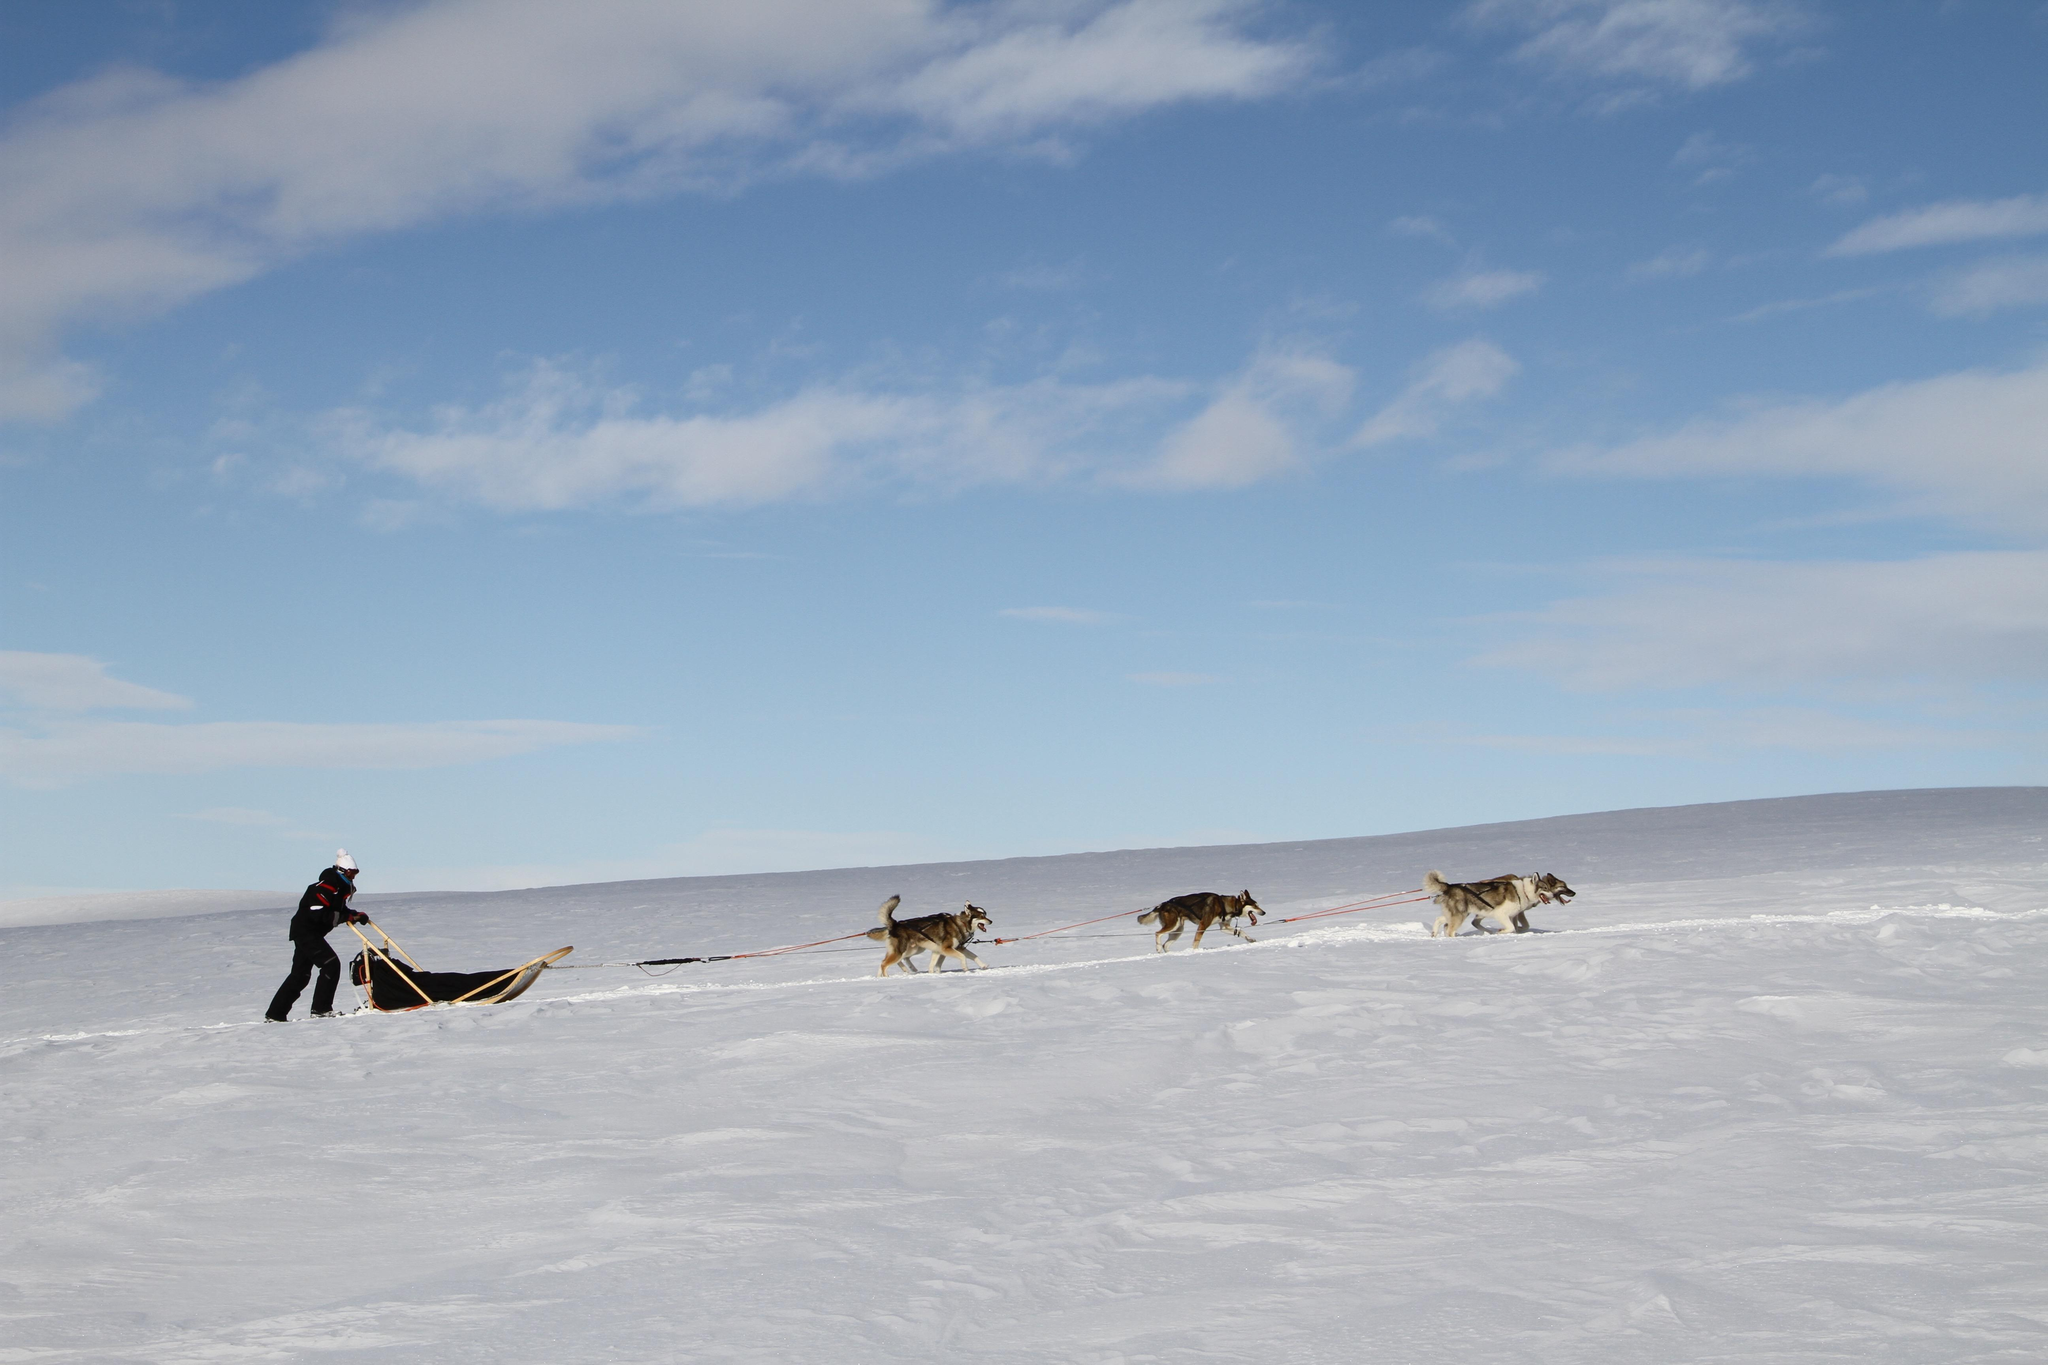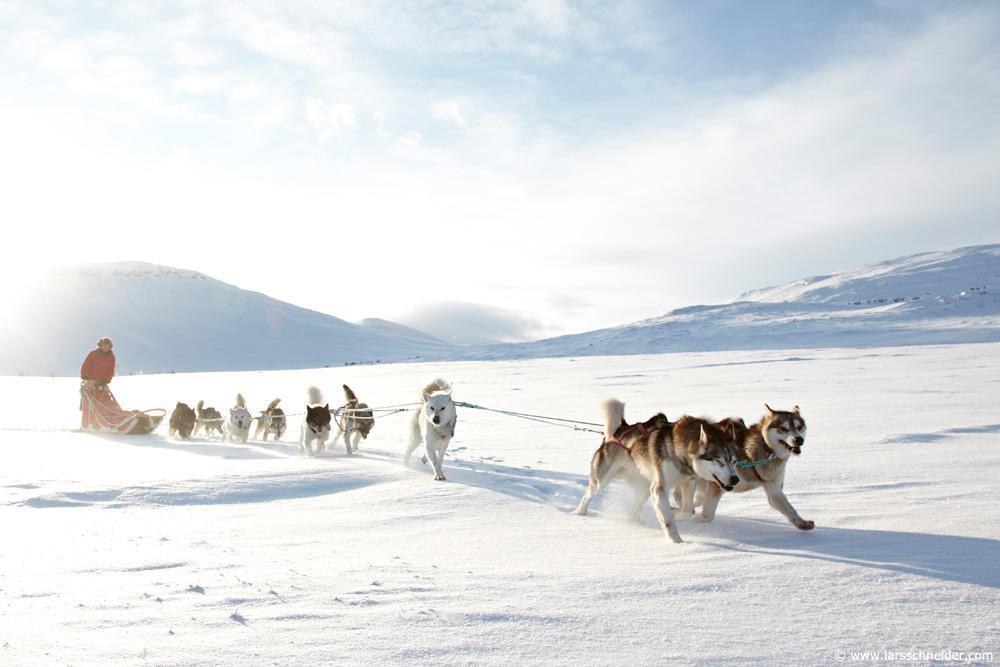The first image is the image on the left, the second image is the image on the right. Examine the images to the left and right. Is the description "There is more than one human visible in at least one of the images." accurate? Answer yes or no. No. The first image is the image on the left, the second image is the image on the right. For the images shown, is this caption "One image features a dog team moving horizontally to the right, and the other image features a dog team heading across the snow at a slight angle." true? Answer yes or no. Yes. 